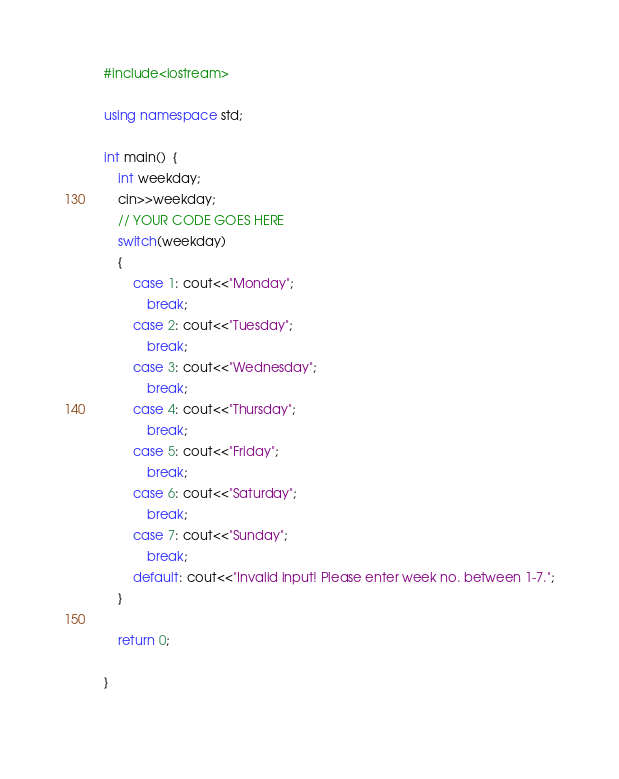Convert code to text. <code><loc_0><loc_0><loc_500><loc_500><_C++_>#include<iostream>

using namespace std;

int main()  {
    int weekday;
    cin>>weekday;
    // YOUR CODE GOES HERE
    switch(weekday)
    {
        case 1: cout<<"Monday";
            break;
        case 2: cout<<"Tuesday";
            break;
        case 3: cout<<"Wednesday";
            break;
        case 4: cout<<"Thursday";
            break;
        case 5: cout<<"Friday";
            break;
        case 6: cout<<"Saturday";
            break;
        case 7: cout<<"Sunday";
            break;
        default: cout<<"Invalid input! Please enter week no. between 1-7.";
    }
 
    return 0;
 
}
    
</code> 